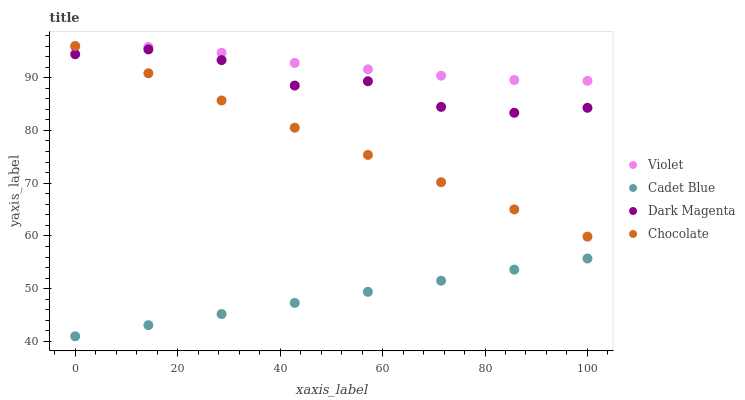Does Cadet Blue have the minimum area under the curve?
Answer yes or no. Yes. Does Violet have the maximum area under the curve?
Answer yes or no. Yes. Does Dark Magenta have the minimum area under the curve?
Answer yes or no. No. Does Dark Magenta have the maximum area under the curve?
Answer yes or no. No. Is Cadet Blue the smoothest?
Answer yes or no. Yes. Is Dark Magenta the roughest?
Answer yes or no. Yes. Is Dark Magenta the smoothest?
Answer yes or no. No. Is Cadet Blue the roughest?
Answer yes or no. No. Does Cadet Blue have the lowest value?
Answer yes or no. Yes. Does Dark Magenta have the lowest value?
Answer yes or no. No. Does Chocolate have the highest value?
Answer yes or no. Yes. Does Dark Magenta have the highest value?
Answer yes or no. No. Is Cadet Blue less than Violet?
Answer yes or no. Yes. Is Violet greater than Cadet Blue?
Answer yes or no. Yes. Does Violet intersect Chocolate?
Answer yes or no. Yes. Is Violet less than Chocolate?
Answer yes or no. No. Is Violet greater than Chocolate?
Answer yes or no. No. Does Cadet Blue intersect Violet?
Answer yes or no. No. 